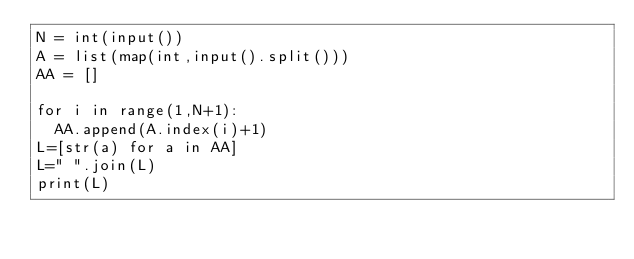<code> <loc_0><loc_0><loc_500><loc_500><_Python_>N = int(input())
A = list(map(int,input().split()))
AA = []

for i in range(1,N+1):
  AA.append(A.index(i)+1)
L=[str(a) for a in AA]
L=" ".join(L)
print(L)</code> 